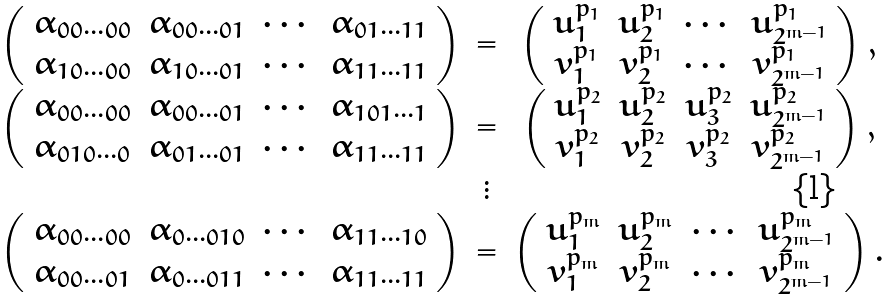Convert formula to latex. <formula><loc_0><loc_0><loc_500><loc_500>\begin{array} { c c c } \left ( \begin{array} { c c c c } \alpha _ { 0 0 \cdots 0 0 } & \alpha _ { 0 0 \cdots 0 1 } & \cdots & \alpha _ { 0 1 \cdots 1 1 } \\ \alpha _ { 1 0 \cdots 0 0 } & \alpha _ { 1 0 \cdots 0 1 } & \cdots & \alpha _ { 1 1 \cdots 1 1 } \\ \end{array} \right ) & = & \left ( \begin{array} { c c c c } u ^ { p _ { 1 } } _ { 1 } & u ^ { p _ { 1 } } _ { 2 } & \cdots & u ^ { p _ { 1 } } _ { 2 ^ { m - 1 } } \\ v ^ { p _ { 1 } } _ { 1 } & v ^ { p _ { 1 } } _ { 2 } & \cdots & v ^ { p _ { 1 } } _ { 2 ^ { m - 1 } } \\ \end{array} \right ) , \\ \left ( \begin{array} { c c c c } \alpha _ { 0 0 \cdots 0 0 } & \alpha _ { 0 0 \cdots 0 1 } & \cdots & \alpha _ { 1 0 1 \cdots 1 } \\ \alpha _ { 0 1 0 \cdots 0 } & \alpha _ { 0 1 \cdots 0 1 } & \cdots & \alpha _ { 1 1 \cdots 1 1 } \\ \end{array} \right ) & = & \left ( \begin{array} { c c c c } u ^ { p _ { 2 } } _ { 1 } & u ^ { p _ { 2 } } _ { 2 } & u ^ { p _ { 2 } } _ { 3 } & u ^ { p _ { 2 } } _ { 2 ^ { m - 1 } } \\ v ^ { p _ { 2 } } _ { 1 } & v ^ { p _ { 2 } } _ { 2 } & v ^ { p _ { 2 } } _ { 3 } & v ^ { p _ { 2 } } _ { 2 ^ { m - 1 } } \\ \end{array} \right ) , \\ & \vdots & \\ \left ( \begin{array} { c c c c } \alpha _ { 0 0 \cdots 0 0 } & \alpha _ { 0 \cdots 0 1 0 } & \cdots & \alpha _ { 1 1 \cdots 1 0 } \\ \alpha _ { 0 0 \cdots 0 1 } & \alpha _ { 0 \cdots 0 1 1 } & \cdots & \alpha _ { 1 1 \cdots 1 1 } \\ \end{array} \right ) & = & \left ( \begin{array} { c c c c } u ^ { p _ { m } } _ { 1 } & u ^ { p _ { m } } _ { 2 } & \cdots & u ^ { p _ { m } } _ { 2 ^ { m - 1 } } \\ v ^ { p _ { m } } _ { 1 } & v ^ { p _ { m } } _ { 2 } & \cdots & v ^ { p _ { m } } _ { 2 ^ { m - 1 } } \\ \end{array} \right ) . \end{array}</formula> 